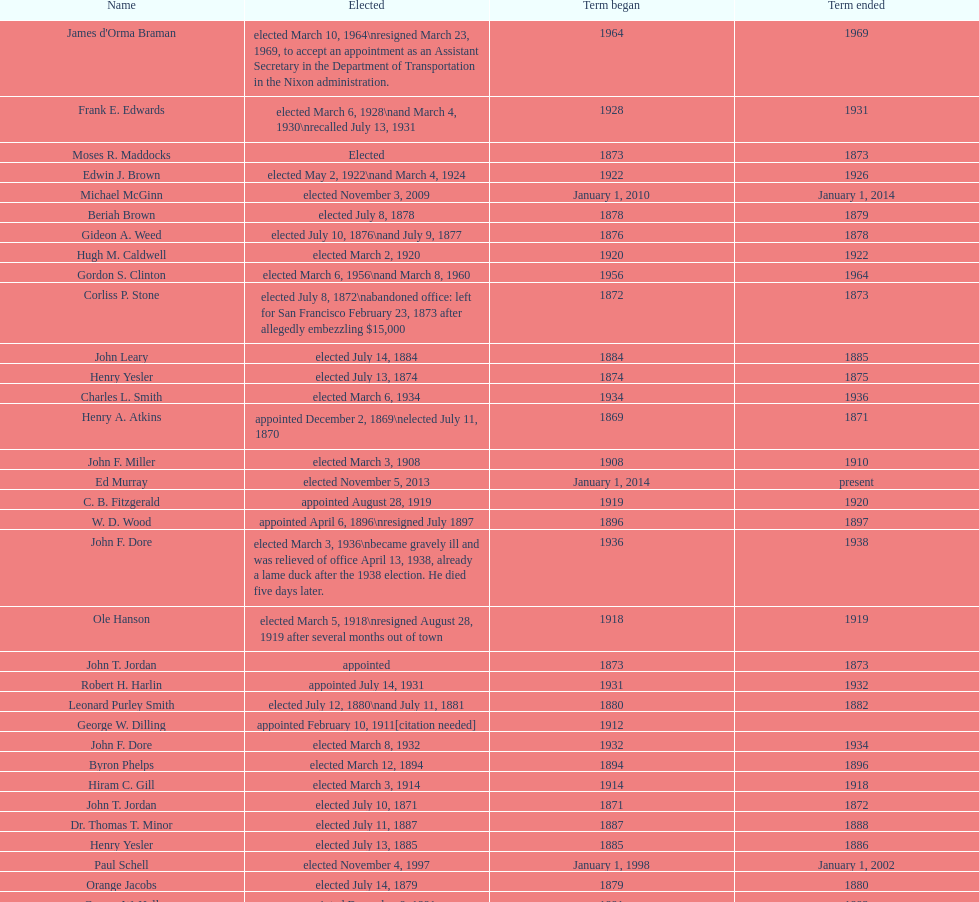Who was the mayor before jordan? Henry A. Atkins. 